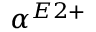<formula> <loc_0><loc_0><loc_500><loc_500>\alpha ^ { E 2 + }</formula> 